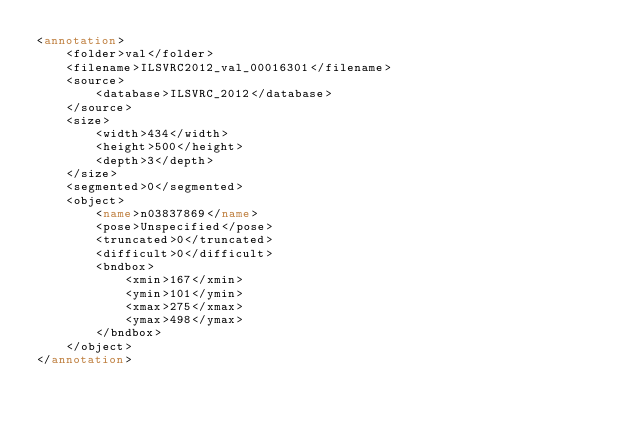Convert code to text. <code><loc_0><loc_0><loc_500><loc_500><_XML_><annotation>
	<folder>val</folder>
	<filename>ILSVRC2012_val_00016301</filename>
	<source>
		<database>ILSVRC_2012</database>
	</source>
	<size>
		<width>434</width>
		<height>500</height>
		<depth>3</depth>
	</size>
	<segmented>0</segmented>
	<object>
		<name>n03837869</name>
		<pose>Unspecified</pose>
		<truncated>0</truncated>
		<difficult>0</difficult>
		<bndbox>
			<xmin>167</xmin>
			<ymin>101</ymin>
			<xmax>275</xmax>
			<ymax>498</ymax>
		</bndbox>
	</object>
</annotation></code> 